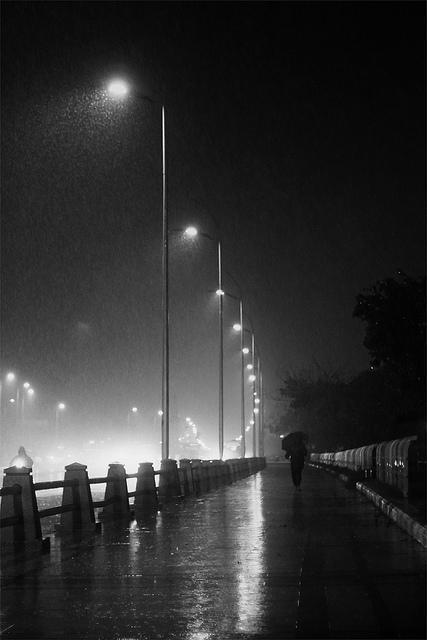How many clocks can be seen in the photo?
Give a very brief answer. 0. 